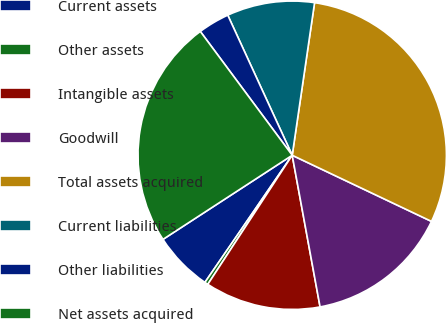Convert chart to OTSL. <chart><loc_0><loc_0><loc_500><loc_500><pie_chart><fcel>Current assets<fcel>Other assets<fcel>Intangible assets<fcel>Goodwill<fcel>Total assets acquired<fcel>Current liabilities<fcel>Other liabilities<fcel>Net assets acquired<nl><fcel>6.24%<fcel>0.36%<fcel>12.11%<fcel>15.05%<fcel>29.74%<fcel>9.18%<fcel>3.3%<fcel>24.02%<nl></chart> 